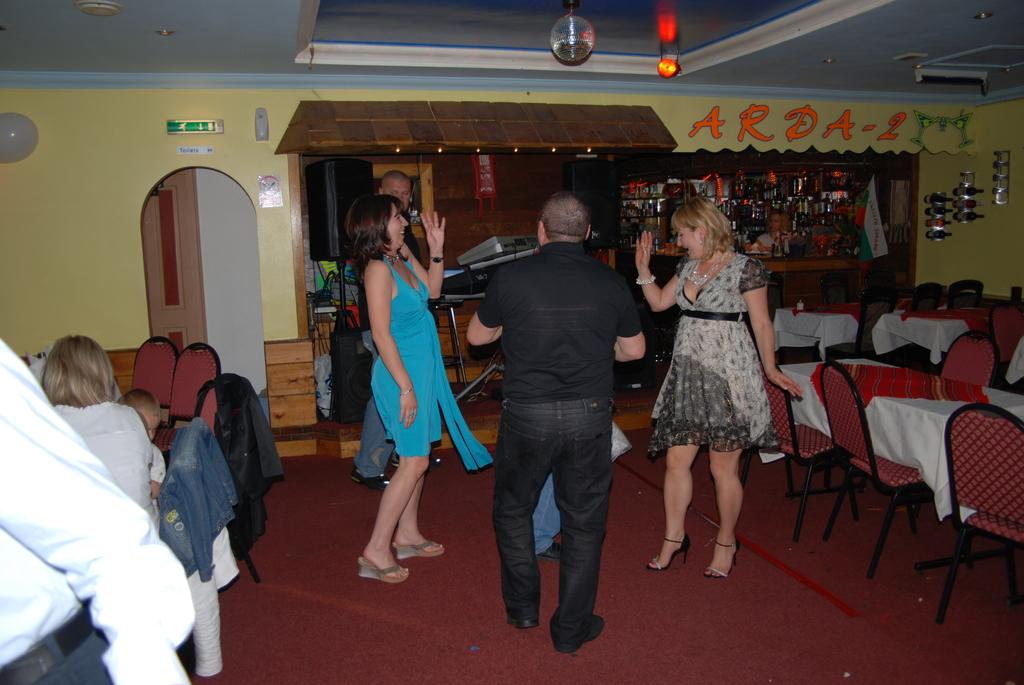What color is the wall that can be seen in the image? The wall in the image is yellow. What object is used for reflecting images in the image? There is a mirror in the image. What are the people in the image doing? The people in the image are sitting and standing. What type of furniture is present in the image? Tables and chairs are visible in the image. How many fish can be seen swimming in the hall in the image? There are no fish or hall present in the image. 